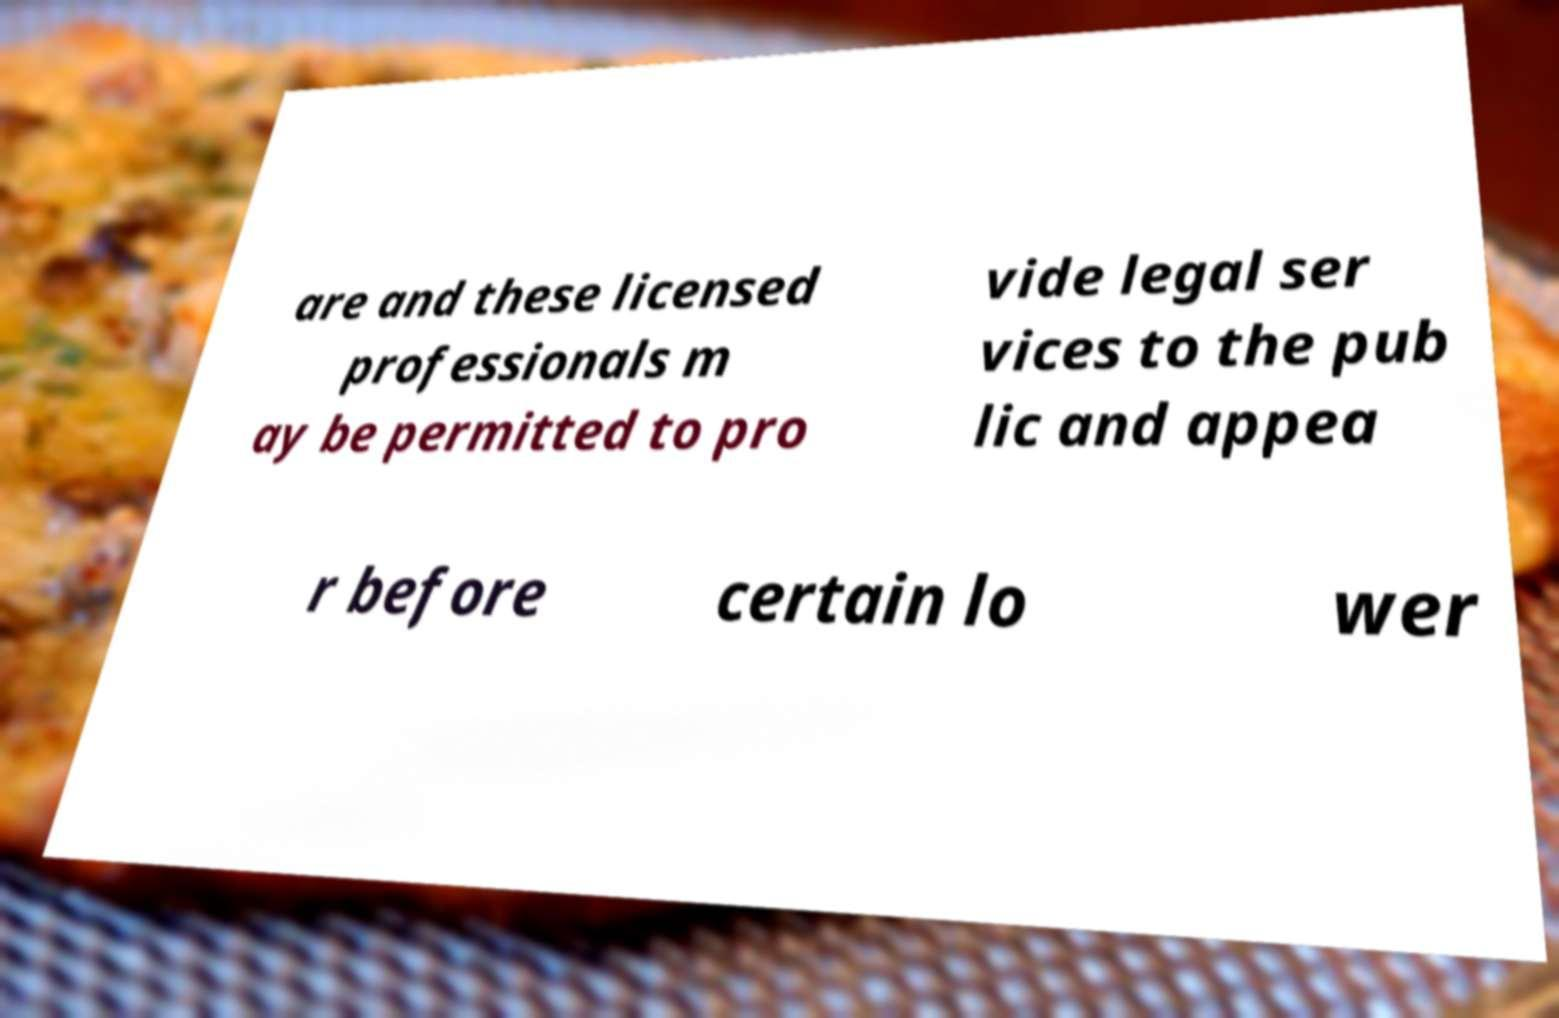Please identify and transcribe the text found in this image. are and these licensed professionals m ay be permitted to pro vide legal ser vices to the pub lic and appea r before certain lo wer 